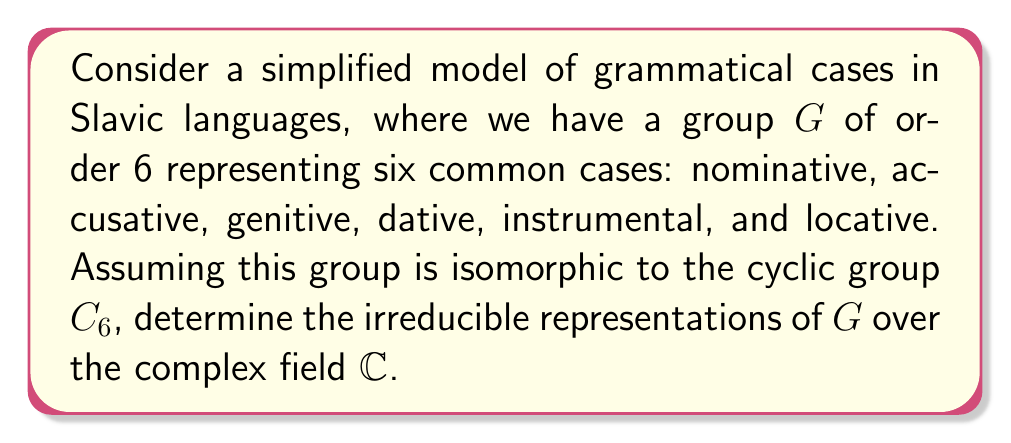Can you solve this math problem? Let's approach this step-by-step:

1) First, recall that for a cyclic group $C_n$ of order $n$, there are exactly $n$ irreducible representations over $\mathbb{C}$, all of dimension 1.

2) For $C_6$, let $g$ be a generator of the group. Then, the irreducible representations $\rho_k$ for $k = 0, 1, 2, 3, 4, 5$ are given by:

   $\rho_k(g^j) = e^{2\pi i k j / 6}$ for $j = 0, 1, 2, 3, 4, 5$

3) Let's express these explicitly:

   $\rho_0(g^j) = 1$ for all $j$ (trivial representation)
   $\rho_1(g^j) = e^{2\pi i j / 6} = \omega^j$, where $\omega = e^{2\pi i / 6}$
   $\rho_2(g^j) = e^{4\pi i j / 6} = (\omega^2)^j$
   $\rho_3(g^j) = e^{6\pi i j / 6} = (-1)^j$
   $\rho_4(g^j) = e^{8\pi i j / 6} = (\omega^4)^j$
   $\rho_5(g^j) = e^{10\pi i j / 6} = (\omega^5)^j$

4) In the context of Slavic cases, we can interpret these representations as follows:
   - $\rho_0$: No change in case (identity)
   - $\rho_1, \rho_5$: Cyclic permutations of cases
   - $\rho_2, \rho_4$: Skip-one cyclic permutations
   - $\rho_3$: Alternating between two sets of cases

These representations could be used to model various grammatical transformations or relationships between cases in Slavic languages.
Answer: The irreducible representations of $G \cong C_6$ over $\mathbb{C}$ are $\rho_k(g^j) = e^{2\pi i k j / 6}$ for $k = 0, 1, 2, 3, 4, 5$ and $j = 0, 1, 2, 3, 4, 5$. 